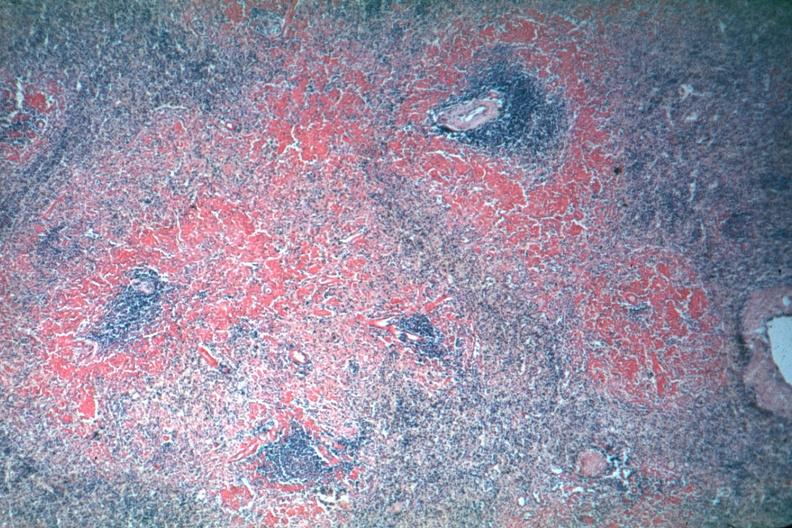re red perifollicular amyloid deposits well shown though exposure is not the best?
Answer the question using a single word or phrase. Yes 